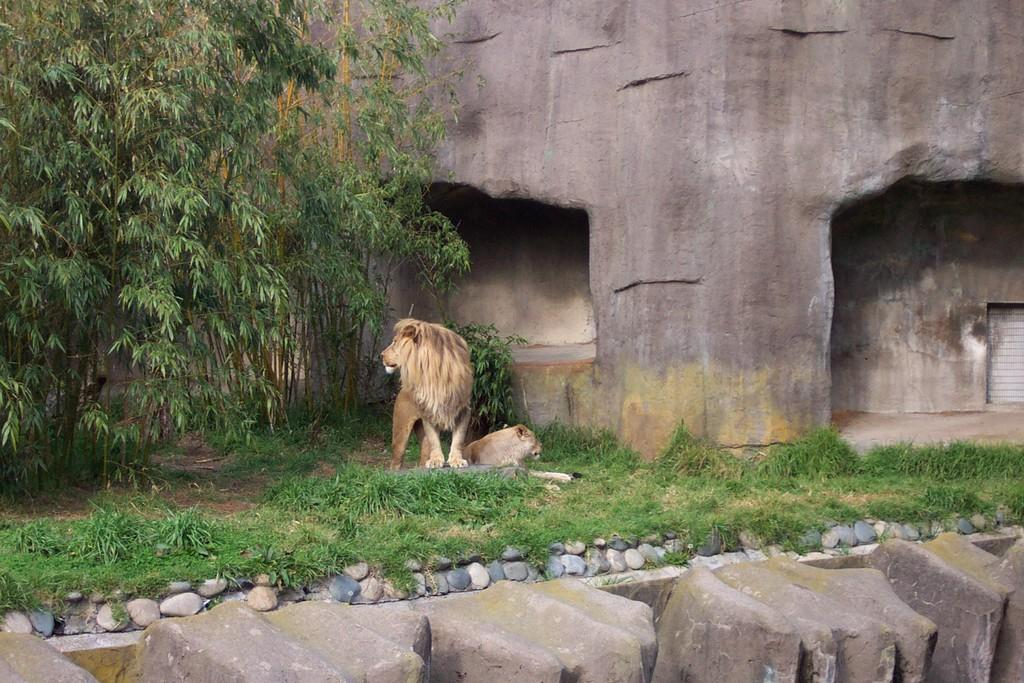What type of natural elements can be seen in the image? There are stones and grass in the image. What other living beings are present in the image? There are animals in the image. What can be seen in the background of the image? There are trees and a wall in the background of the image. How many hours do the animals in the image sleep? The provided facts do not mention the sleeping habits of the animals in the image, so it cannot be determined from the image. 